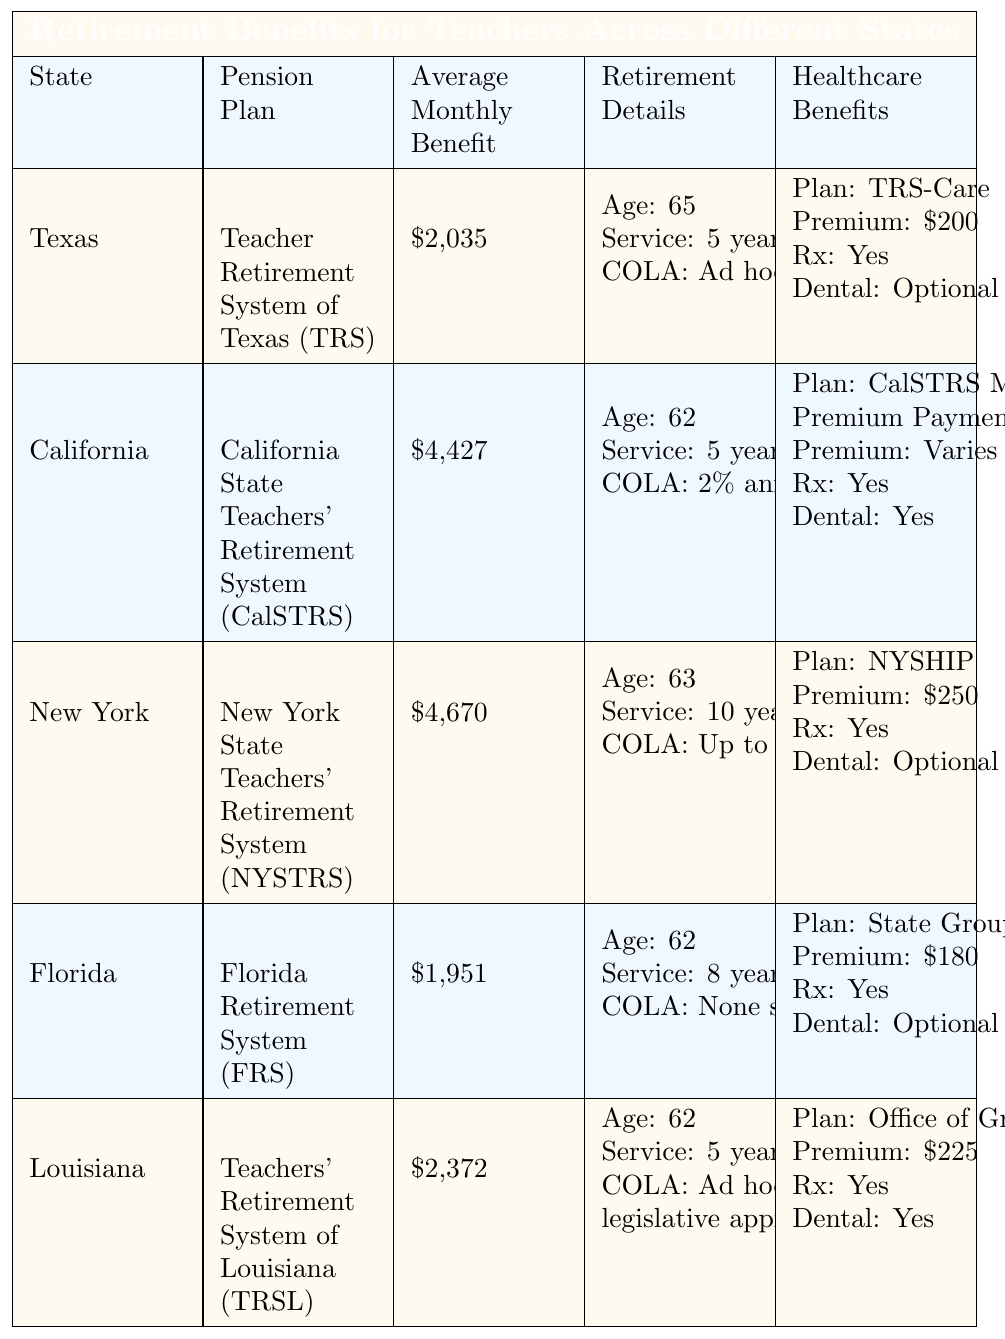What is the average monthly benefit for teachers in California? According to the table, the average monthly benefit listed for California is $4,427.
Answer: $4,427 Which state has the highest average monthly benefit? By reviewing the table, New York has the highest average monthly benefit at $4,670.
Answer: New York What is the pension plan for Texas teachers? The pension plan specified for Texas is the Teacher Retirement System of Texas (TRS).
Answer: Teacher Retirement System of Texas (TRS) In which state do teachers require the most years of service to retire? The table shows that New York requires 10 years of service, which is more than any other state.
Answer: New York Does Florida provide a cost of living adjustment (COLA) for retirees? The data indicates that Florida has not provided a COLA since 2011, so the answer is no.
Answer: No Which states provide healthcare benefits with prescription coverage? By examining the healthcare benefits in each state’s section, all states listed—Texas, California, New York, Florida, and Louisiana—provide prescription coverage.
Answer: All states What is the difference in average monthly benefits between Louisiana and Florida? The average monthly benefit for Louisiana is $2,372, while Florida's is $1,951. The difference is $2,372 - $1,951 = $421.
Answer: $421 How many states have a retirement age of 62? From the table, both California, Florida, and Louisiana have a retirement age of 62. This makes a total of 3 states.
Answer: 3 Which state has healthcare benefits with a lower monthly premium, Texas or New York? The table shows Texas has a healthcare premium of $200 and New York has $250, so Texas has the lower premium.
Answer: Texas Is the average monthly benefit for California more than double that of Texas? The average for California is $4,427 and for Texas is $2,035. Doubling Texas' average gives $4,070, which is less than California's average benefit of $4,427, so the answer is yes.
Answer: Yes 